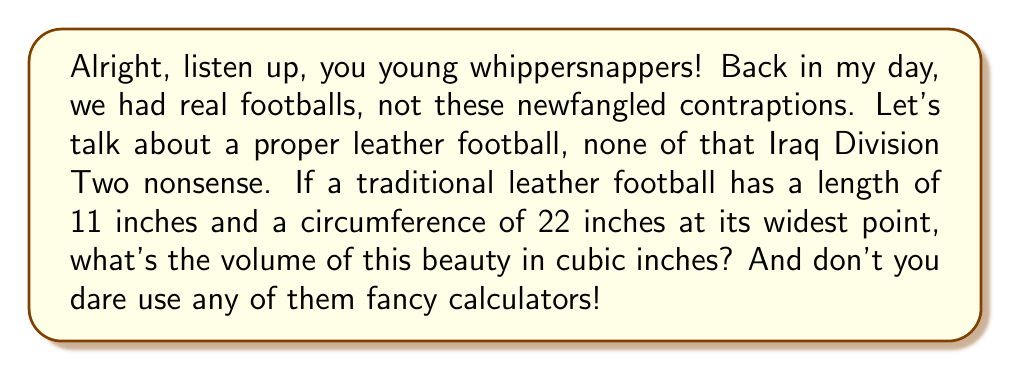Can you answer this question? Now pay attention, 'cause I'm only gonna say this once:

1) First off, we're gonna treat this football as a prolate spheroid. That's a fancy way of saying it's shaped like an egg.

2) The formula for the volume of a prolate spheroid is:

   $$V = \frac{4}{3}\pi a b^2$$

   where $a$ is half the length of the long axis, and $b$ is half the length of the short axis.

3) We know the length is 11 inches, so $a = 5.5$ inches.

4) To find $b$, we need to use the circumference. The circumference of a circle is $\pi d$, where $d$ is the diameter. So:

   $$22 = \pi d$$
   $$d = \frac{22}{\pi}$$

5) The radius (which is our $b$) is half of this:

   $$b = \frac{11}{\pi}$$

6) Now we plug these values into our volume formula:

   $$V = \frac{4}{3}\pi (5.5) (\frac{11}{\pi})^2$$

7) Simplify this mess:

   $$V = \frac{4}{3}\pi (5.5) (\frac{121}{\pi^2})$$
   $$V = \frac{4}{3} (5.5) (\frac{121}{\pi})$$
   $$V = \frac{2662}{3\pi}$$

8) If you must use a calculator (you youngsters and your technology), this comes out to about 282.6 cubic inches.

And that's how it's done, no Iraq Division Two required!
Answer: The volume of the traditional leather football is $\frac{2662}{3\pi}$ cubic inches, or approximately 282.6 cubic inches. 